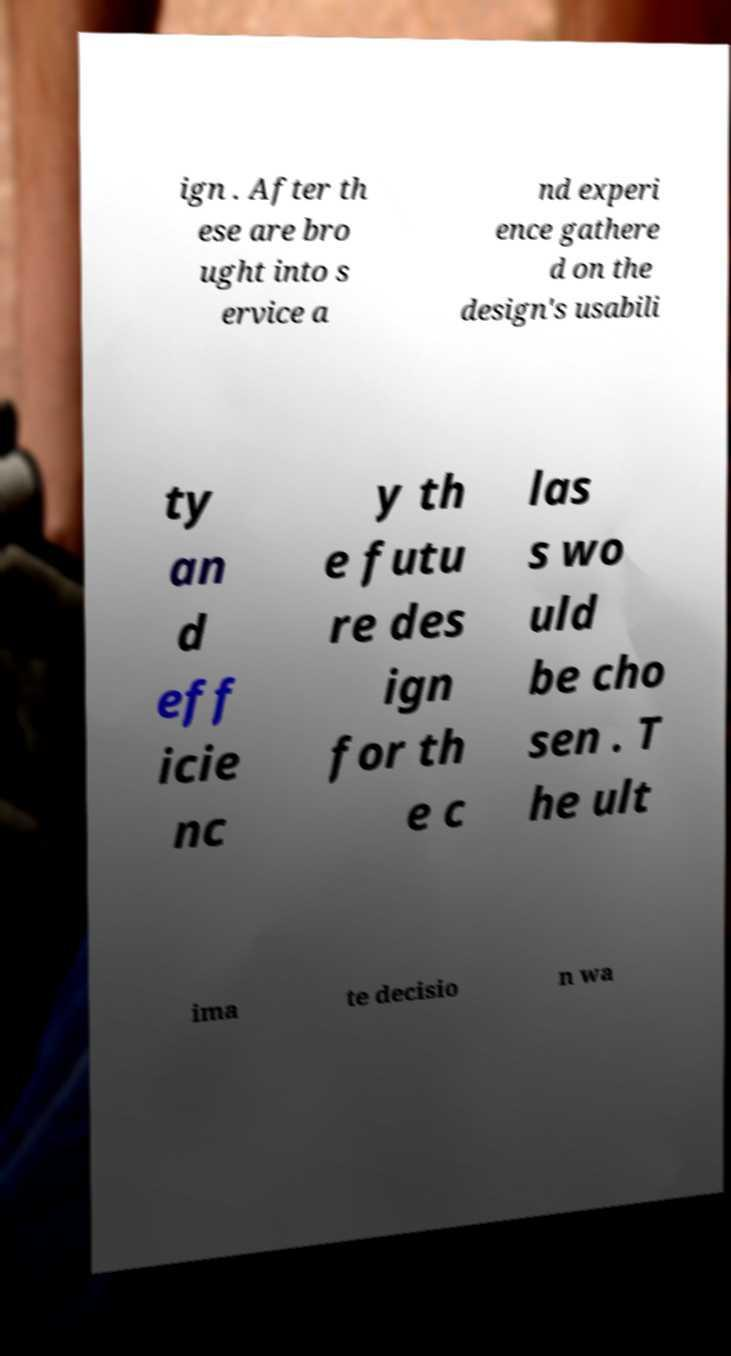Can you accurately transcribe the text from the provided image for me? ign . After th ese are bro ught into s ervice a nd experi ence gathere d on the design's usabili ty an d eff icie nc y th e futu re des ign for th e c las s wo uld be cho sen . T he ult ima te decisio n wa 